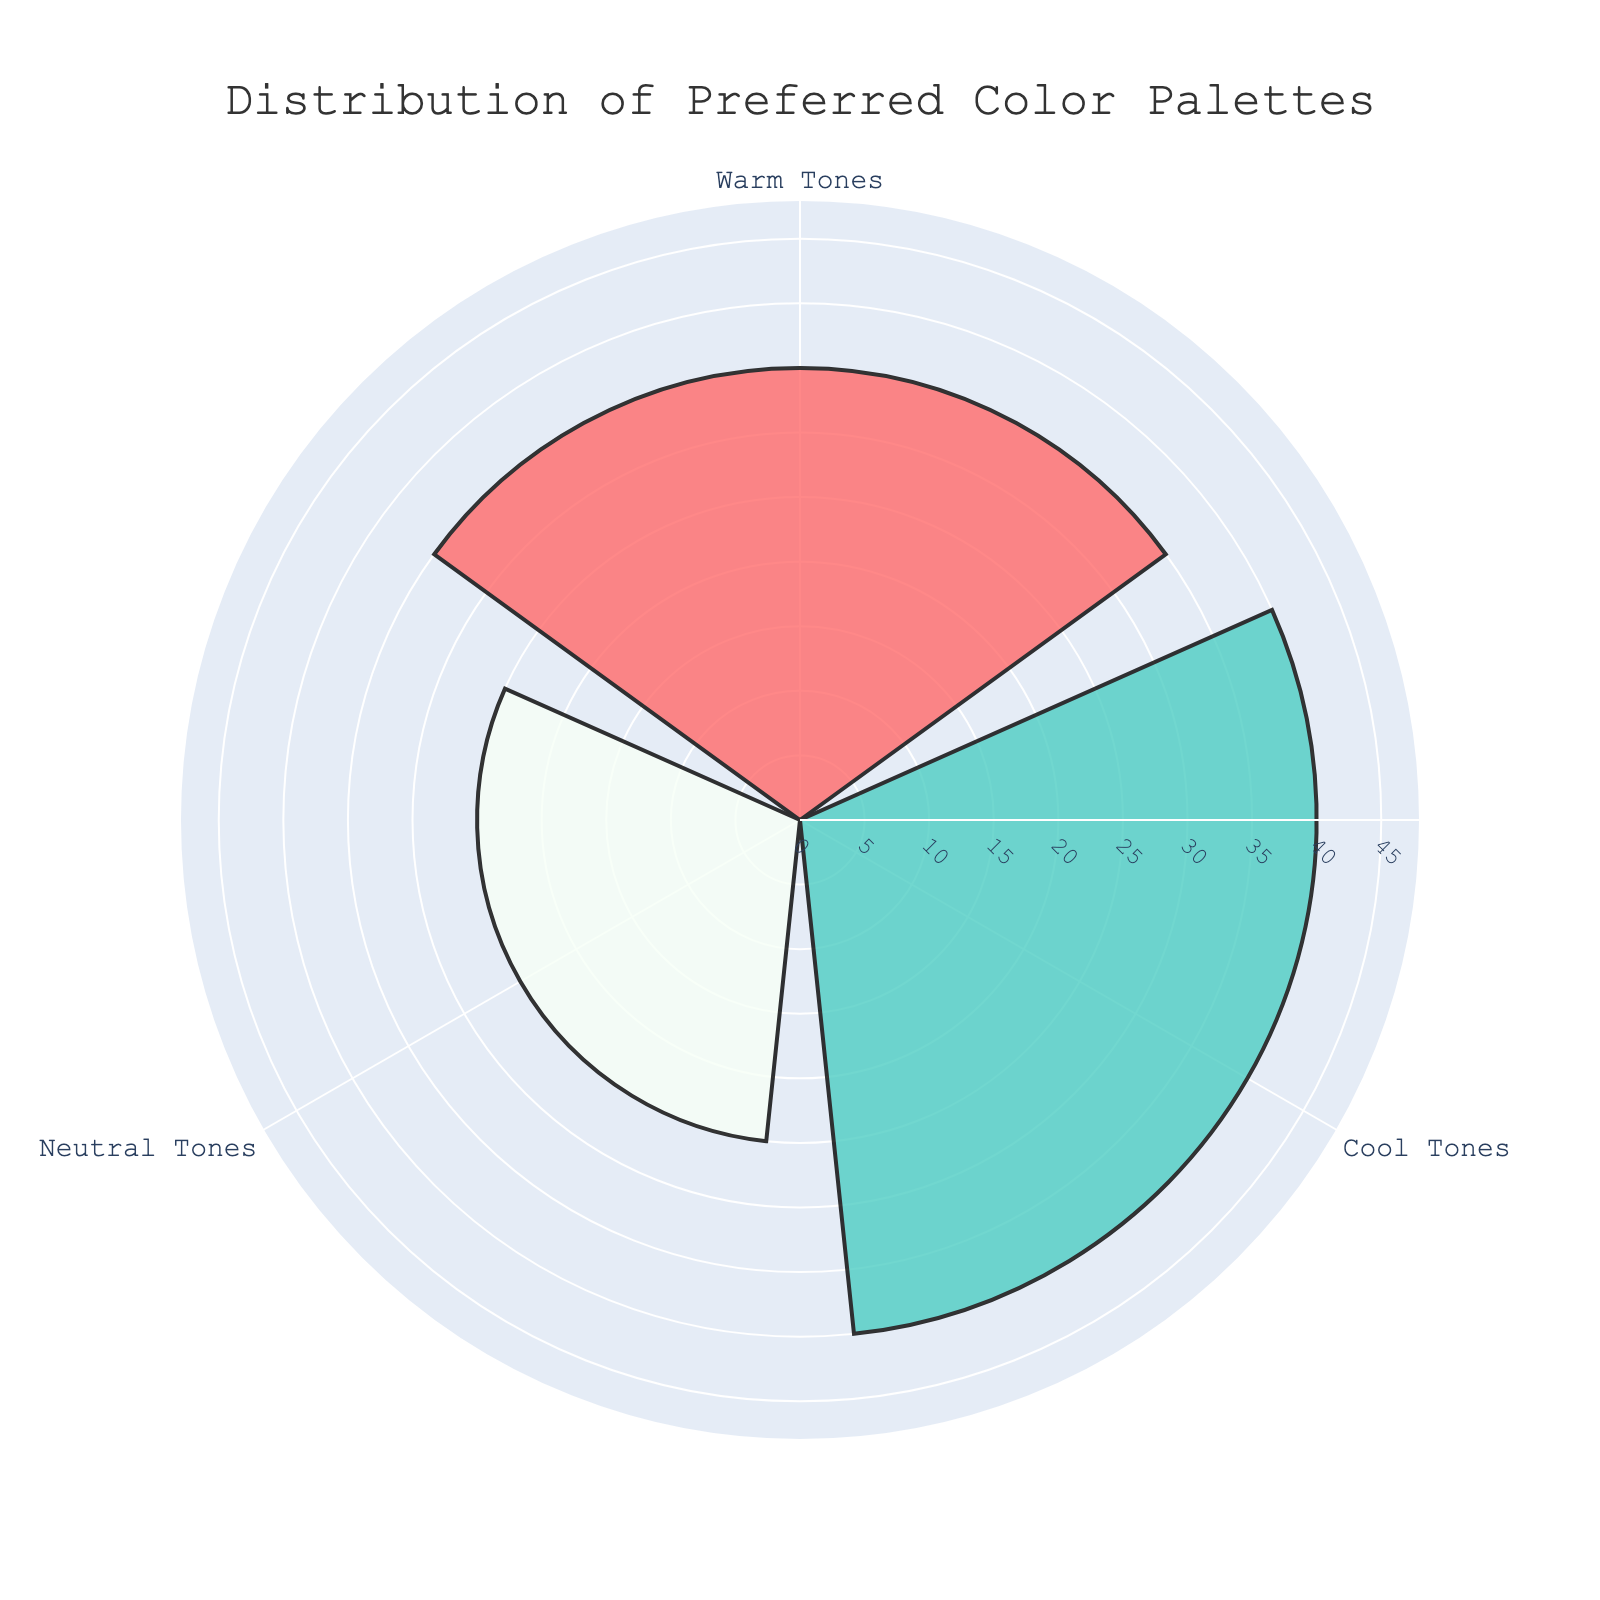How many groups are represented in the figure? The figure is a rose chart with one bar per group color-coded distinctly. By counting the different color-coded bars, we can see there are three distinct groups.
Answer: Three What is the group with the highest occurrence, and how many instances does it have? Look at the bar that extends farthest from the center; it is labeled "Cool Tones." By referring to this bar's specific length, we find it represents 40 occurrences.
Answer: Cool Tones, 40 Which group has the lowest occurrence, and how does it compare to the highest occurrence? Identify the shortest bar, labeled "Neutral Tones," which has 25 occurrences. The difference between 40 (Cool Tones) and 25 (Neutral Tones) is calculated as 40 - 25 = 15.
Answer: Neutral Tones, 15 less than Cool Tones How many instances are represented by the warm tones palette? Find the bar labeled "Warm Tones." The length of this bar corresponds to its values, which is labeled as 35 occurrences.
Answer: 35 What is the sum of occurrences for all groups together? Add all the occurrence values: Warm Tones (35) + Cool Tones (40) + Neutral Tones (25). The sum is 35 + 40 + 25 = 100.
Answer: 100 Which palette has an occurrence closest to the average occurrence value of palettes represented? Calculate the average: Sum of occurrences (100) divided by the number of groups (3) gives an average of 100 / 3 ≈ 33.33. Warm Tones has 35 occurrences which is closest to 33.33.
Answer: Warm Tones What percentage of the total occurrences does the group with the highest occurrence represent? Calculate the total occurrences (100). Cool Tones occurrences (40) divided by this total gives 40 / 100 = 0.4. Multiply by 100 to convert to a percentage: 0.4 * 100 = 40%.
Answer: 40% List the groups in ascending order of their occurrences. Compare the occurrences: Neutral Tones (25), Warm Tones (35), Cool Tones (40). Arrange them in ascending order by occurrences.
Answer: Neutral Tones, Warm Tones, Cool Tones If the number of instances of the Cool Tones went down by 10, what would be the new total distribution? Subtract 10 occurrences from Cool Tones (40) resulting in 30. Update the total by summing the new values: 35 (Warm Tones) + 30 (Cool Tones) + 25 (Neutral Tones) = 90.
Answer: 90 